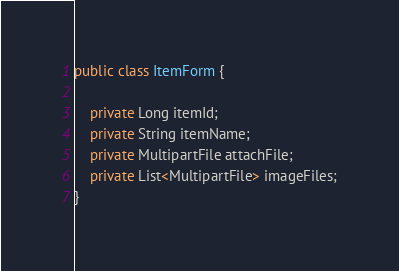<code> <loc_0><loc_0><loc_500><loc_500><_Java_>public class ItemForm {

    private Long itemId;
    private String itemName;
    private MultipartFile attachFile;
    private List<MultipartFile> imageFiles;
}
</code> 